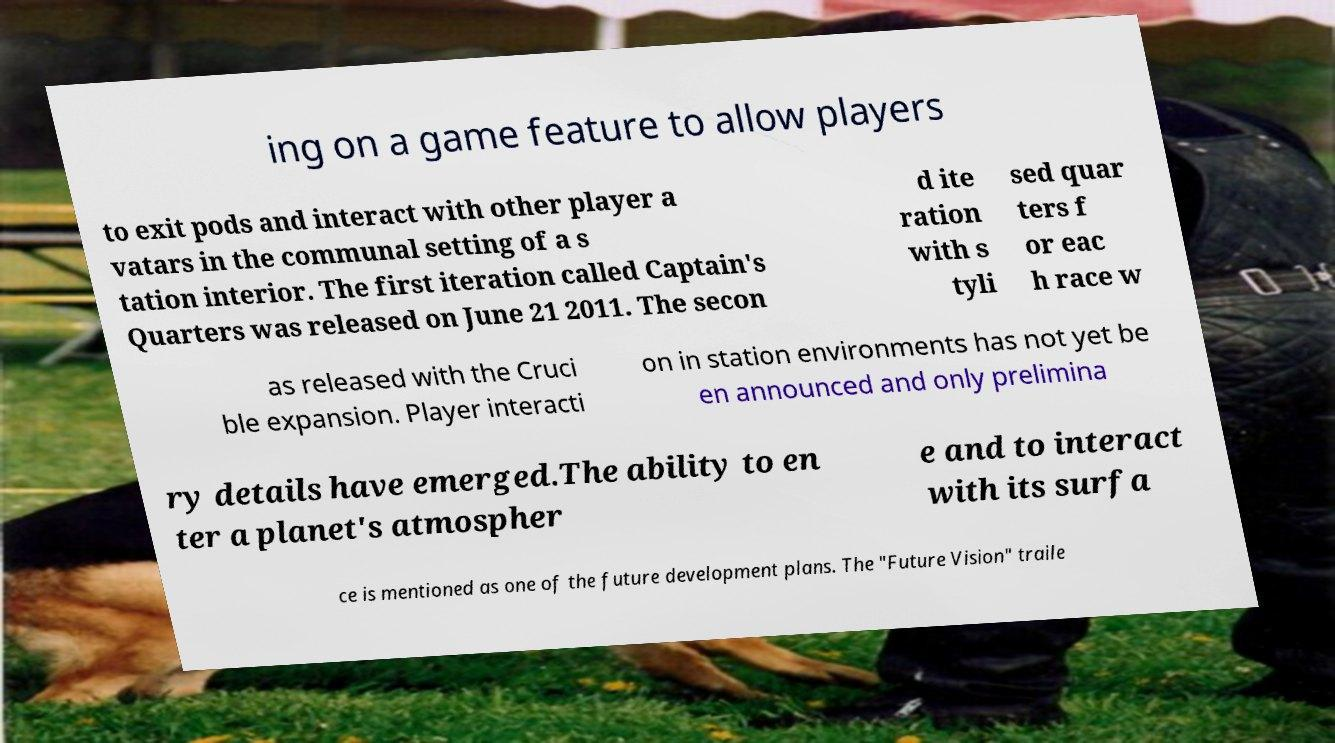Could you extract and type out the text from this image? ing on a game feature to allow players to exit pods and interact with other player a vatars in the communal setting of a s tation interior. The first iteration called Captain's Quarters was released on June 21 2011. The secon d ite ration with s tyli sed quar ters f or eac h race w as released with the Cruci ble expansion. Player interacti on in station environments has not yet be en announced and only prelimina ry details have emerged.The ability to en ter a planet's atmospher e and to interact with its surfa ce is mentioned as one of the future development plans. The "Future Vision" traile 